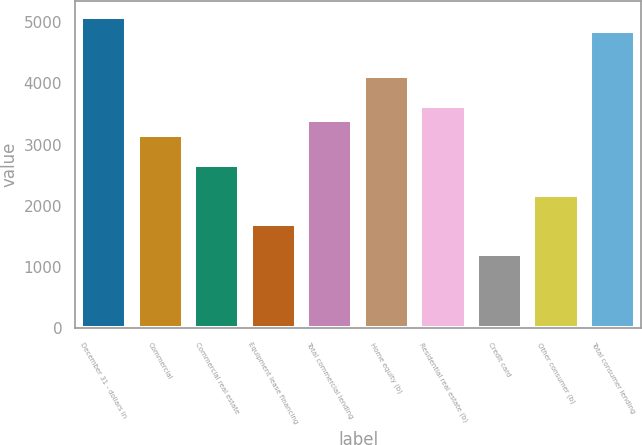Convert chart to OTSL. <chart><loc_0><loc_0><loc_500><loc_500><bar_chart><fcel>December 31 - dollars in<fcel>Commercial<fcel>Commercial real estate<fcel>Equipment lease financing<fcel>Total commercial lending<fcel>Home equity (b)<fcel>Residential real estate (b)<fcel>Credit card<fcel>Other consumer (b)<fcel>Total consumer lending<nl><fcel>5092.16<fcel>3152.4<fcel>2667.46<fcel>1697.58<fcel>3394.87<fcel>4122.28<fcel>3637.34<fcel>1212.64<fcel>2182.52<fcel>4849.69<nl></chart> 